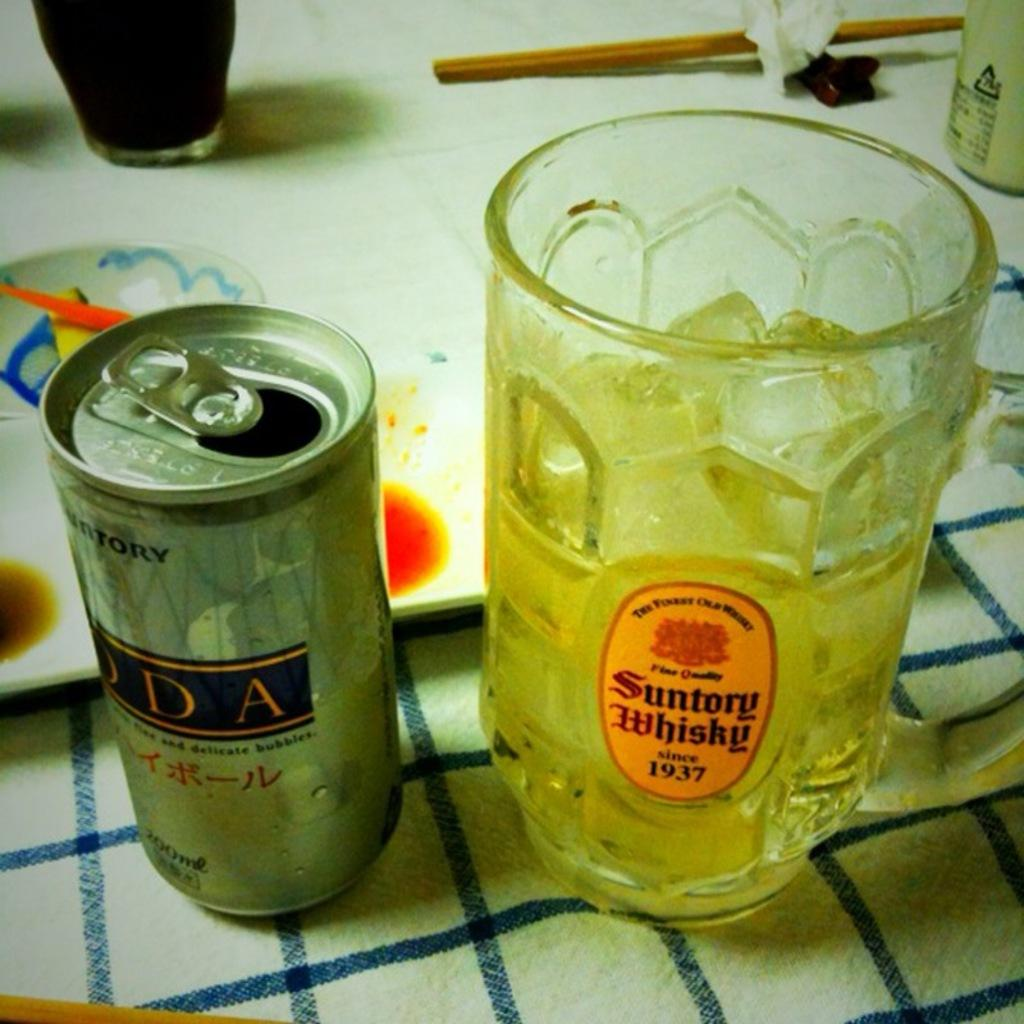<image>
Provide a brief description of the given image. An open can next to a Suntory Whisky glass with ice and liquid. 